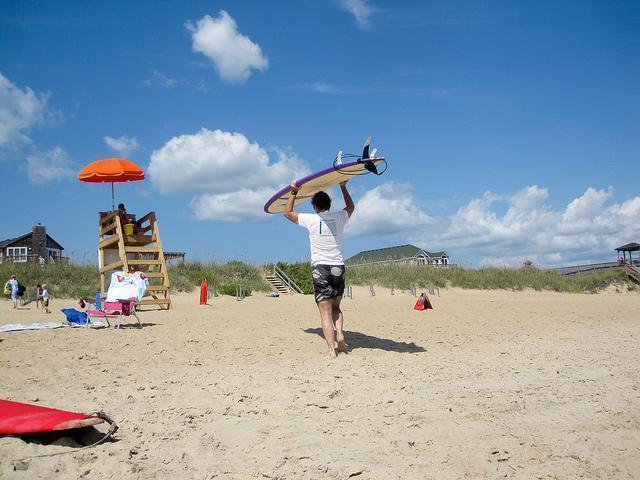What kind of view might be seen from the windows on the house?
Indicate the correct response by choosing from the four available options to answer the question.
Options: Dirt view, sky view, office view, sea view. Sea view. 